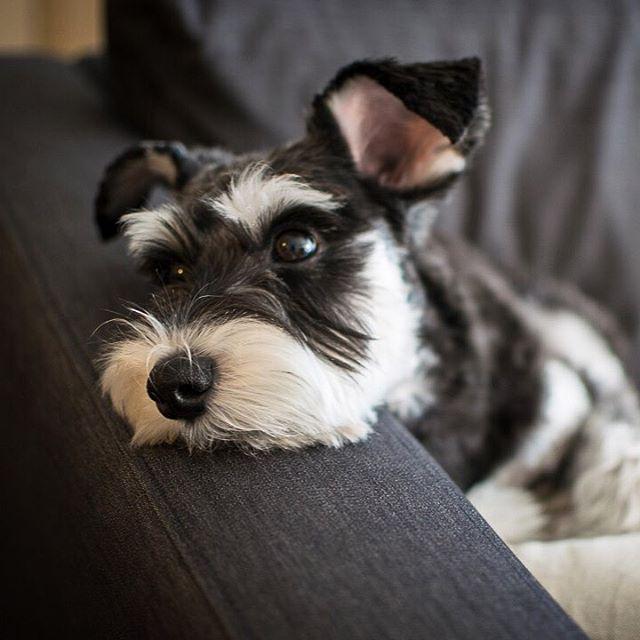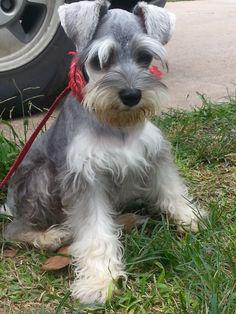The first image is the image on the left, the second image is the image on the right. Given the left and right images, does the statement "The left image shows one schnauzer with its paws propped over and its head poking out of a container, which is draped with something white." hold true? Answer yes or no. No. The first image is the image on the left, the second image is the image on the right. Given the left and right images, does the statement "In one of the images there is a dog on a leash." hold true? Answer yes or no. Yes. 